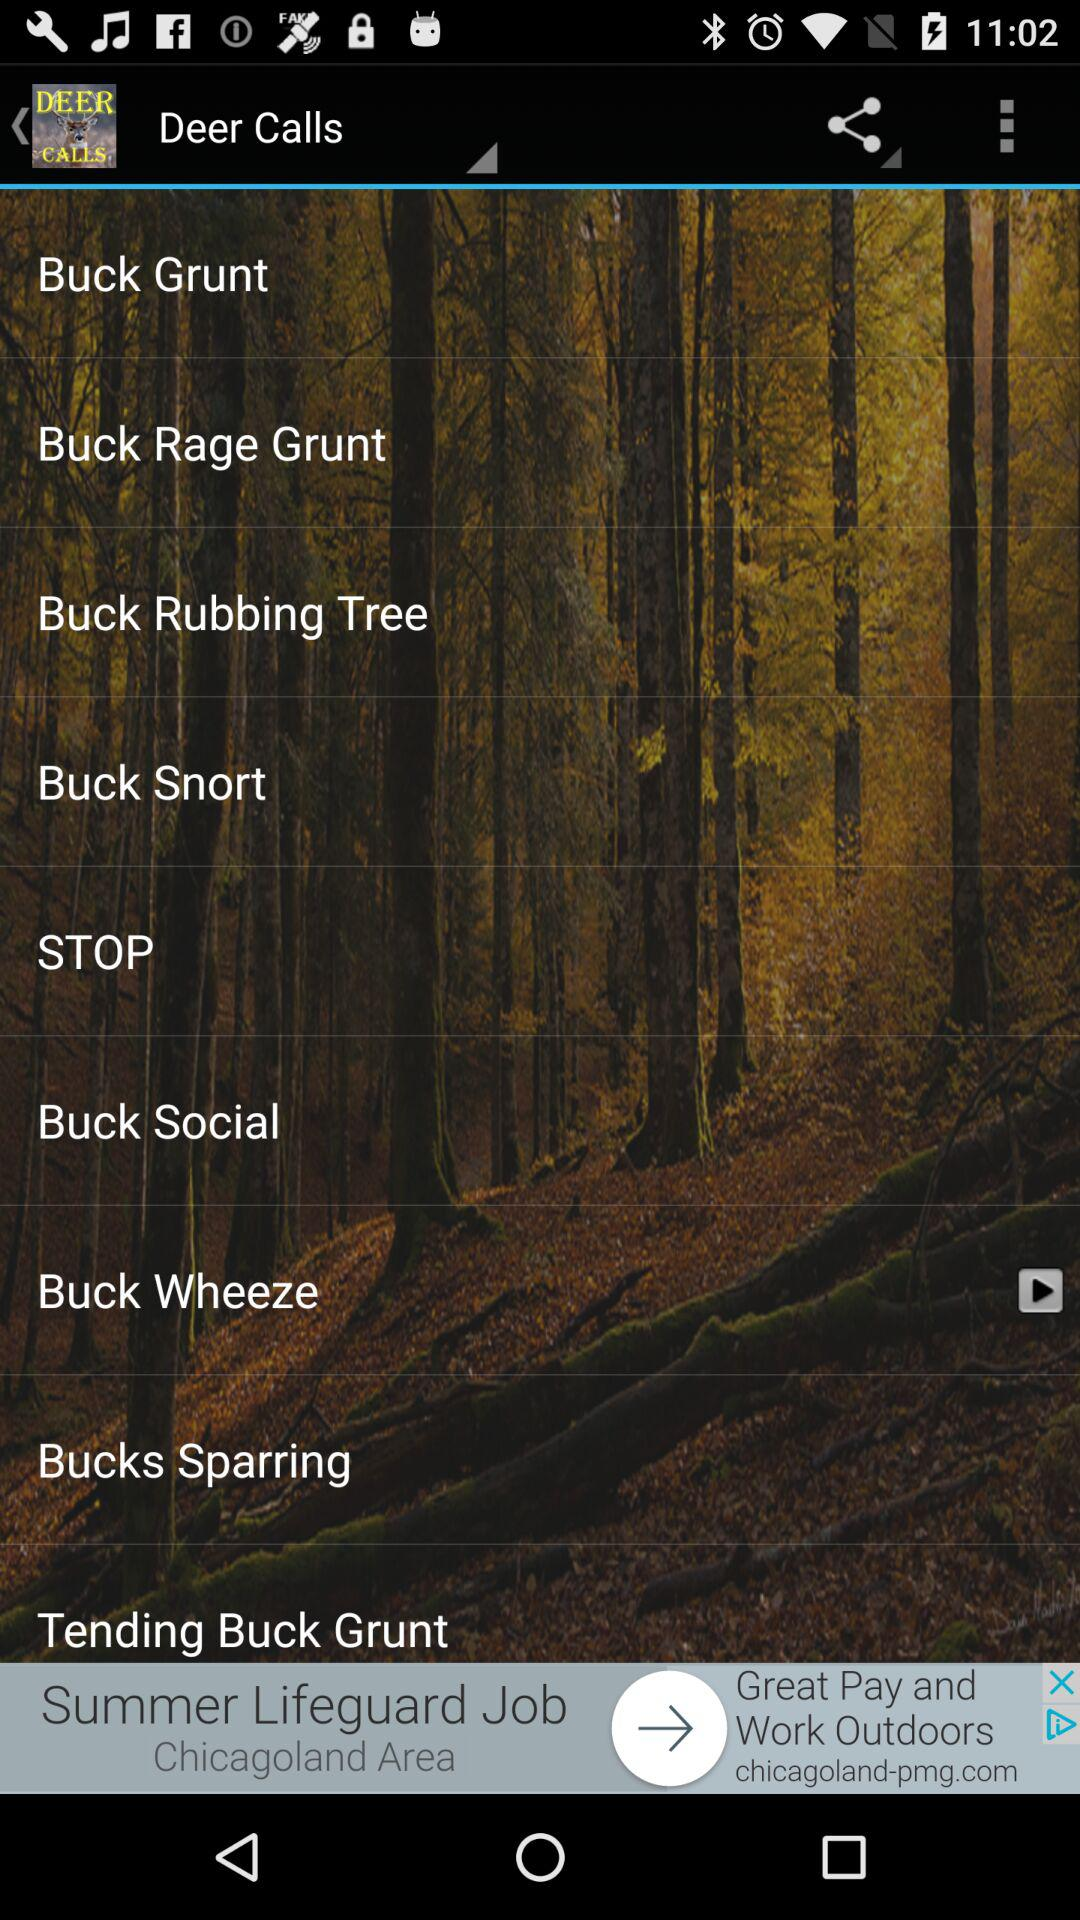What is the name of the application? The name of the application is "Deer Calls HD". 